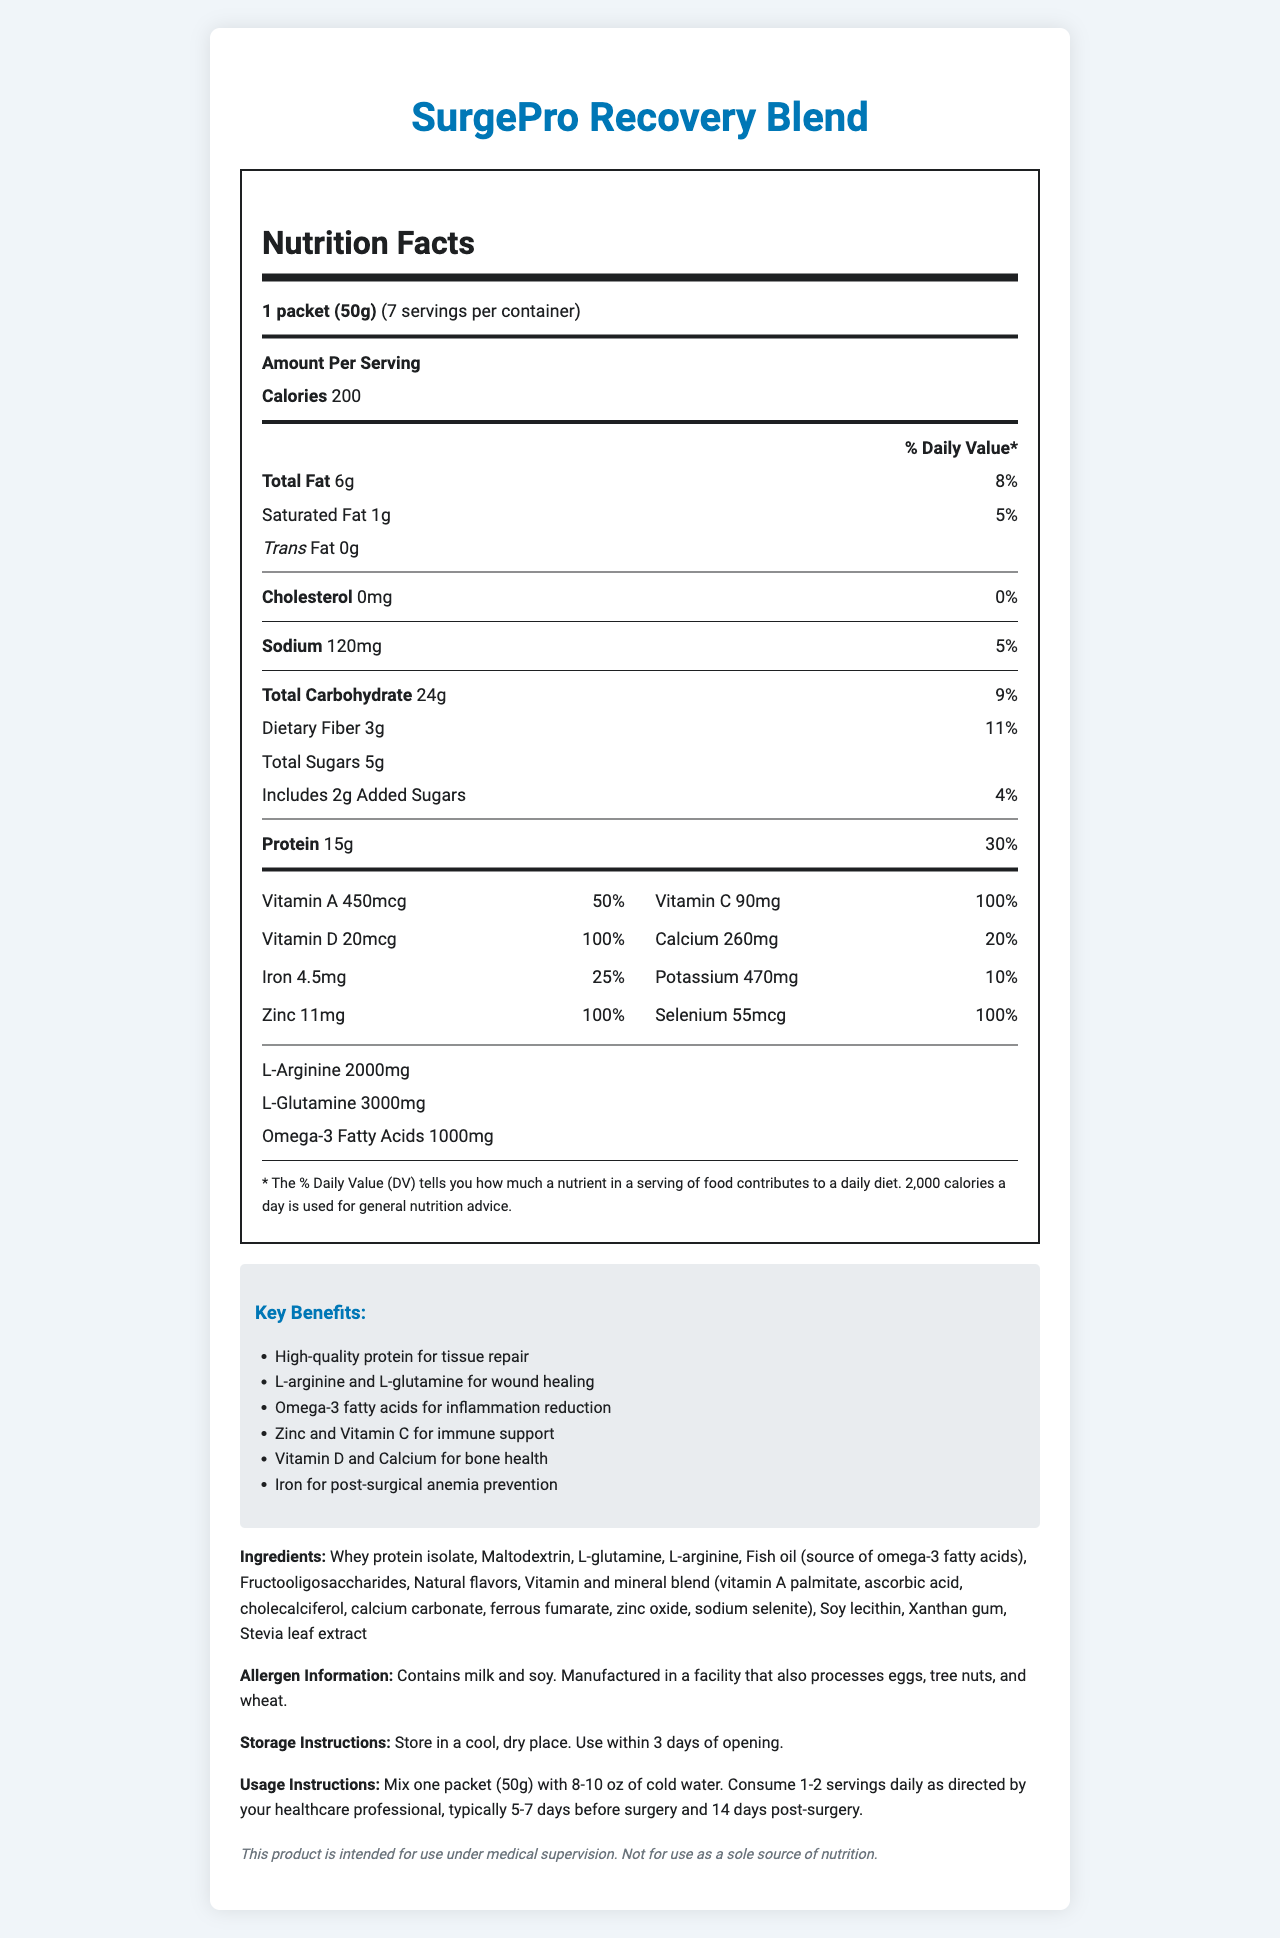How many servings are there per container? The document states "servings per container: 7".
Answer: 7 What is the serving size for SurgePro Recovery Blend? The document mentions "serving size: 1 packet (50g)".
Answer: 1 packet (50g) How many calories are in one serving? The document lists "calories: 200".
Answer: 200 calories What percentage of the daily value does 15g of protein contribute? The document states "Protein: 15g (30% Daily Value)".
Answer: 30% What are the key benefits of SurgePro Recovery Blend? The document includes a section titled "Key Benefits" which lists these benefits.
Answer: High-quality protein for tissue repair, L-arginine and L-glutamine for wound healing, Omega-3 fatty acids for inflammation reduction, Zinc and Vitamin C for immune support, Vitamin D and Calcium for bone health, Iron for post-surgical anemia prevention Which of the following vitamins in SurgePro Recovery Blend has a daily value percentage of 100%? a) Vitamin A b) Vitamin C c) Vitamin D d) Iron The document shows that Vitamin D has 100% daily value.
Answer: c Which ingredient is a source of omega-3 fatty acids in SurgePro Recovery Blend? a) L-arginine b) Soy lecithin c) Fish oil d) Xanthan gum The document lists "Fish oil (source of omega-3 fatty acids)" as one of the ingredients.
Answer: c Is SurgePro Recovery Blend suitable for people allergic to milk and soy? The document contains an allergen information section stating it "Contains milk and soy".
Answer: No Does SurgePro Recovery Blend contain any cholesterol? The document states "Cholesterol: 0mg (0% daily value)".
Answer: No Which of the following is not an ingredient in SurgePro Recovery Blend? a) Maltodextrin b) Fructooligosaccharides c) Sodium selenite d) Vitamin B12 The document lists all ingredients, and Vitamin B12 is not included.
Answer: d What are the items included in the vitamin and mineral blend? The document specifies these items under the "ingredients" section.
Answer: Vitamin A palmitate, ascorbic acid, cholecalciferol, calcium carbonate, ferrous fumarate, zinc oxide, sodium selenite Does SurgePro Recovery Blend provide any dietary fiber per serving? The document states "Dietary Fiber: 3g (11% daily value)".
Answer: Yes Summarize the key features of the SurgePro Recovery Blend nutritional supplement. The document elaborates extensively on these key points, including the nutritional facts, ingredients, and benefits specifically laid out.
Answer: SurgePro Recovery Blend is a pre-operative nutritional supplement designed to aid surgical recovery. Each serving is 50g, providing 200 calories. It includes essential nutrients such as 15g of protein, vitamins A, C, and D, calcium, iron, potassium, zinc, and selenium. The supplement also contains L-arginine, L-glutamine, and omega-3 fatty acids. Key benefits include support for tissue repair, wound healing, inflammation reduction, immune support, bone health, and anemia prevention. What is the recommended usage instruction for SurgePro Recovery Blend before and after surgery? The document provides specific usage instructions under the "usage instructions" section.
Answer: Mix one packet (50g) with 8-10 oz of cold water. Consume 1-2 servings daily as directed by your healthcare professional, typically 5-7 days before surgery and 14 days post-surgery. How many grams of trans fat does SurgePro Recovery Blend contain per serving? The document clearly states "Trans Fat: 0g".
Answer: 0g Is it known whether the manufacturing facility also processes peanuts? The document only mentions that the facility processes eggs, tree nuts, and wheat, but does not mention peanuts.
Answer: Not enough information 